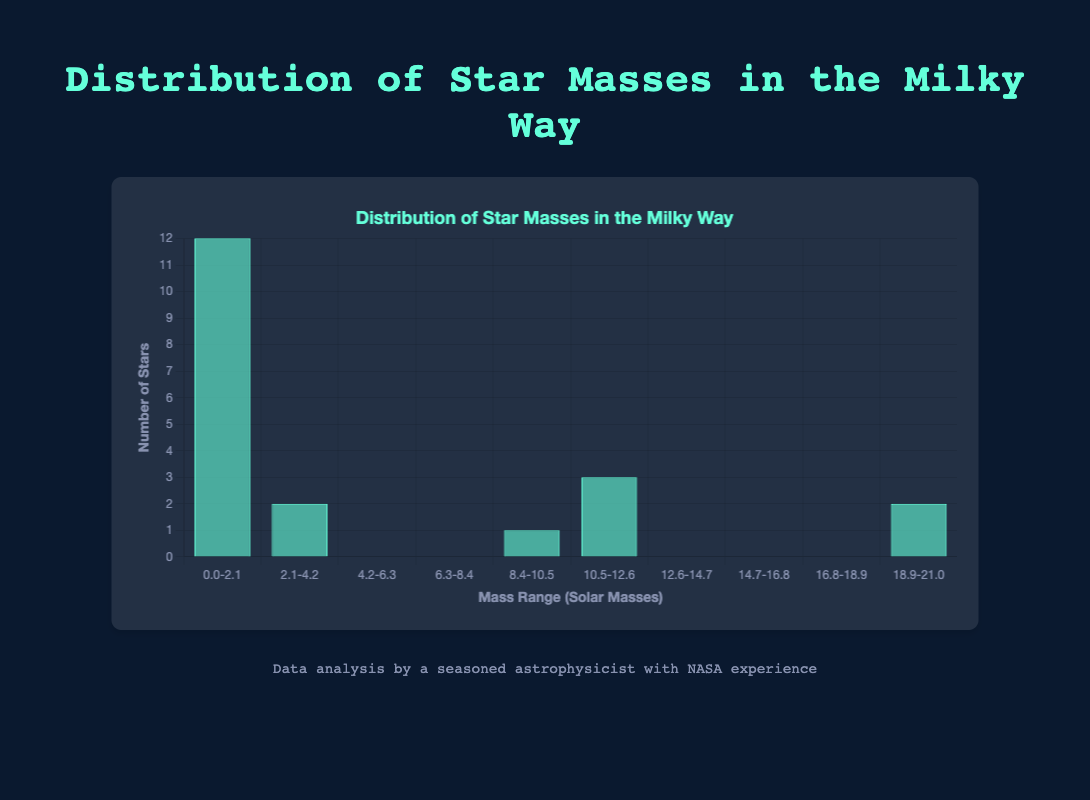What is the title of the figure? The title is displayed prominently at the top of the figure. It reads "Distribution of Star Masses in the Milky Way".
Answer: Distribution of Star Masses in the Milky Way How many bins are there in the histogram? By looking at the x-axis of the histogram, it is clear that there are 10 labeled intervals, representing 10 bins.
Answer: 10 Which bin range has the highest number of stars? Examine the heights of the bars in the histogram and find the tallest bar. The tallest bar is in the range "0.0-2.1".
Answer: 0.0-2.1 How many stars are in the bin range 0.0-2.1? Locate the bar corresponding to the bin range 0.0-2.1 and look at its height. This bar reaches up to 12 on the y-axis.
Answer: 12 Compare the number of stars in the bin range 0.0-2.1 to the bin range 2.1-4.2. Which has more stars? Examine the heights of the bars for the bin ranges 0.0-2.1 and 2.1-4.2. The 0.0-2.1 bin (height 12) is taller than the 2.1-4.2 bin (height 5).
Answer: 0.0-2.1 What is the total number of stars represented in the histogram? Add the heights of all the bars: 12 + 5 + 0 + 0 + 0 + 0 + 1 + 0 + 1 + 1 = 20.
Answer: 20 In which mass range is there only one star? Identify the bars with a height of 1. The bars at bin ranges 12.6-14.7, 16.8-18.9, and 18.9-21.0 each have a height of 1.
Answer: 12.6-14.7, 16.8-18.9, 18.9-21.0 Is there any bin range with no stars? Look for bars with a height of 0. The bars for the bin ranges 4.2-6.3, 6.3-8.4, 8.4-10.5, 10.5-12.6, 14.7-16.8 have a height of 0.
Answer: 4.2-6.3, 6.3-8.4, 8.4-10.5, 10.5-12.6, 14.7-16.8 